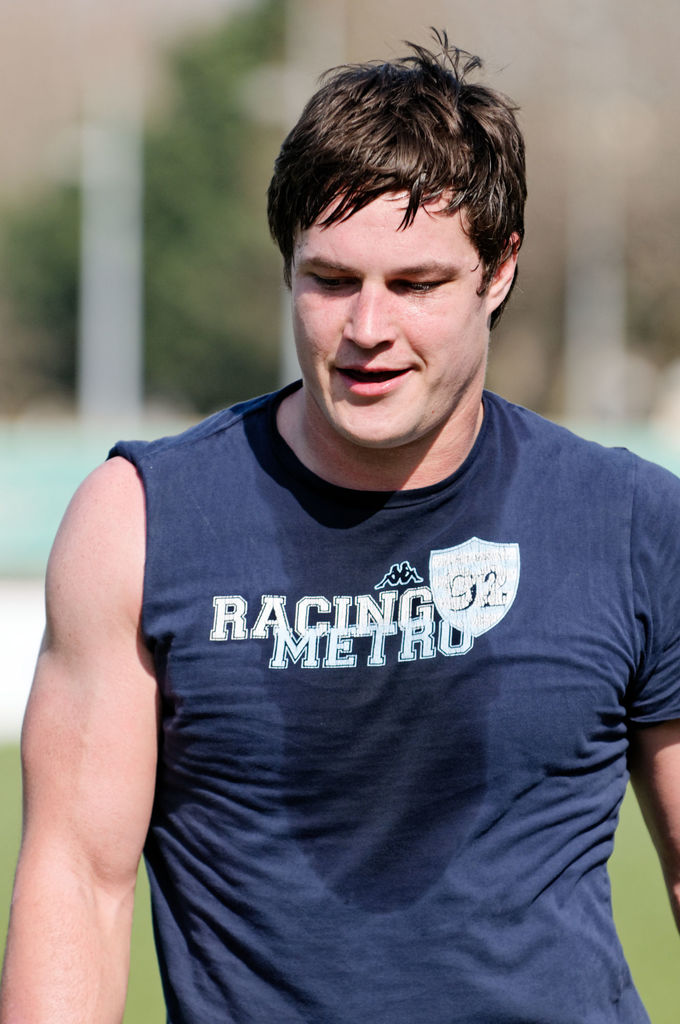What emotions or state of mind does the person in this image convey? The man's relaxed facial expression and loose posture suggest he is taking a moment to rest and recover, perhaps after physical exertion, reflecting a sense of fatigue but also satisfaction from the activity. 